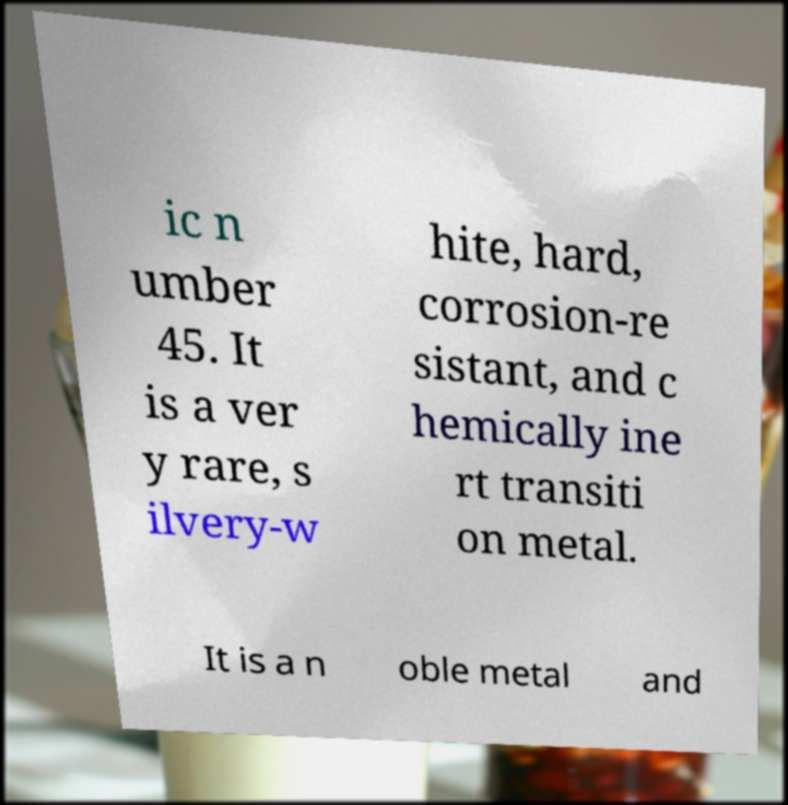Could you assist in decoding the text presented in this image and type it out clearly? ic n umber 45. It is a ver y rare, s ilvery-w hite, hard, corrosion-re sistant, and c hemically ine rt transiti on metal. It is a n oble metal and 